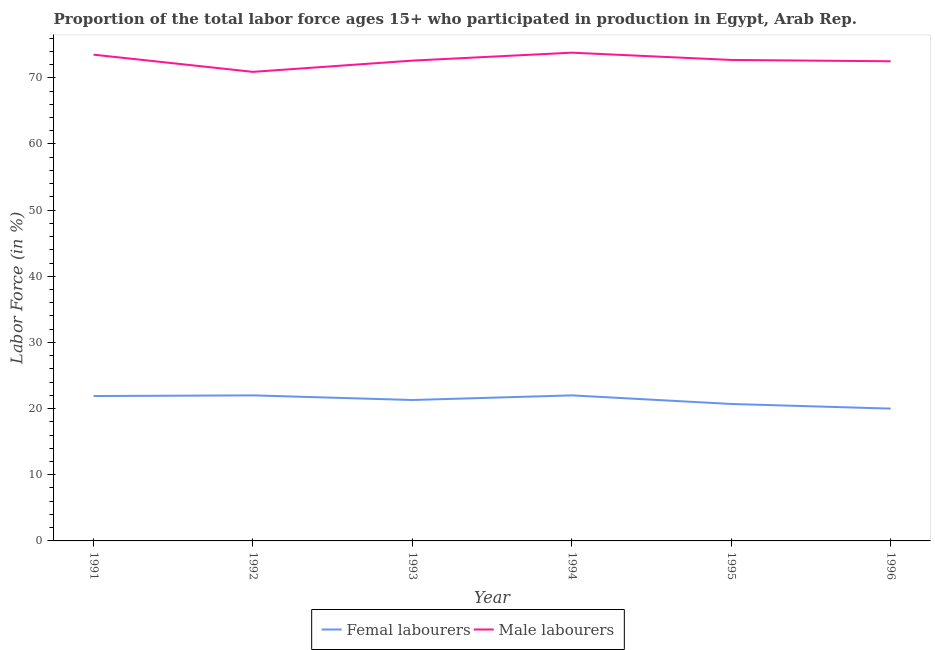How many different coloured lines are there?
Offer a very short reply. 2. What is the percentage of male labour force in 1994?
Keep it short and to the point. 73.8. Across all years, what is the minimum percentage of male labour force?
Give a very brief answer. 70.9. In which year was the percentage of male labour force minimum?
Provide a succinct answer. 1992. What is the total percentage of female labor force in the graph?
Your response must be concise. 127.9. What is the difference between the percentage of male labour force in 1994 and that in 1995?
Your answer should be compact. 1.1. What is the difference between the percentage of female labor force in 1992 and the percentage of male labour force in 1993?
Keep it short and to the point. -50.6. What is the average percentage of female labor force per year?
Your answer should be very brief. 21.32. In the year 1995, what is the difference between the percentage of male labour force and percentage of female labor force?
Offer a terse response. 52. What is the ratio of the percentage of female labor force in 1991 to that in 1992?
Your answer should be very brief. 1. Is the difference between the percentage of male labour force in 1991 and 1994 greater than the difference between the percentage of female labor force in 1991 and 1994?
Your response must be concise. No. In how many years, is the percentage of male labour force greater than the average percentage of male labour force taken over all years?
Your answer should be compact. 3. Is the percentage of female labor force strictly greater than the percentage of male labour force over the years?
Provide a succinct answer. No. How many years are there in the graph?
Provide a short and direct response. 6. What is the difference between two consecutive major ticks on the Y-axis?
Offer a terse response. 10. Are the values on the major ticks of Y-axis written in scientific E-notation?
Provide a short and direct response. No. Does the graph contain any zero values?
Provide a succinct answer. No. Does the graph contain grids?
Offer a very short reply. No. How many legend labels are there?
Provide a short and direct response. 2. What is the title of the graph?
Provide a short and direct response. Proportion of the total labor force ages 15+ who participated in production in Egypt, Arab Rep. Does "Goods" appear as one of the legend labels in the graph?
Your response must be concise. No. What is the label or title of the X-axis?
Offer a terse response. Year. What is the Labor Force (in %) of Femal labourers in 1991?
Your answer should be compact. 21.9. What is the Labor Force (in %) of Male labourers in 1991?
Your response must be concise. 73.5. What is the Labor Force (in %) of Male labourers in 1992?
Provide a short and direct response. 70.9. What is the Labor Force (in %) in Femal labourers in 1993?
Ensure brevity in your answer.  21.3. What is the Labor Force (in %) of Male labourers in 1993?
Offer a very short reply. 72.6. What is the Labor Force (in %) of Male labourers in 1994?
Provide a succinct answer. 73.8. What is the Labor Force (in %) of Femal labourers in 1995?
Provide a short and direct response. 20.7. What is the Labor Force (in %) of Male labourers in 1995?
Give a very brief answer. 72.7. What is the Labor Force (in %) of Male labourers in 1996?
Your answer should be very brief. 72.5. Across all years, what is the maximum Labor Force (in %) of Male labourers?
Your response must be concise. 73.8. Across all years, what is the minimum Labor Force (in %) in Femal labourers?
Provide a short and direct response. 20. Across all years, what is the minimum Labor Force (in %) in Male labourers?
Offer a very short reply. 70.9. What is the total Labor Force (in %) in Femal labourers in the graph?
Make the answer very short. 127.9. What is the total Labor Force (in %) in Male labourers in the graph?
Your response must be concise. 436. What is the difference between the Labor Force (in %) in Femal labourers in 1991 and that in 1992?
Provide a short and direct response. -0.1. What is the difference between the Labor Force (in %) of Male labourers in 1991 and that in 1993?
Offer a terse response. 0.9. What is the difference between the Labor Force (in %) of Male labourers in 1991 and that in 1994?
Make the answer very short. -0.3. What is the difference between the Labor Force (in %) of Femal labourers in 1991 and that in 1995?
Keep it short and to the point. 1.2. What is the difference between the Labor Force (in %) in Male labourers in 1991 and that in 1995?
Your answer should be compact. 0.8. What is the difference between the Labor Force (in %) of Femal labourers in 1991 and that in 1996?
Offer a terse response. 1.9. What is the difference between the Labor Force (in %) of Male labourers in 1991 and that in 1996?
Your response must be concise. 1. What is the difference between the Labor Force (in %) in Femal labourers in 1992 and that in 1995?
Give a very brief answer. 1.3. What is the difference between the Labor Force (in %) in Femal labourers in 1992 and that in 1996?
Your answer should be compact. 2. What is the difference between the Labor Force (in %) of Male labourers in 1993 and that in 1995?
Provide a short and direct response. -0.1. What is the difference between the Labor Force (in %) in Male labourers in 1993 and that in 1996?
Offer a very short reply. 0.1. What is the difference between the Labor Force (in %) of Femal labourers in 1994 and that in 1995?
Make the answer very short. 1.3. What is the difference between the Labor Force (in %) of Femal labourers in 1994 and that in 1996?
Your response must be concise. 2. What is the difference between the Labor Force (in %) in Male labourers in 1994 and that in 1996?
Provide a short and direct response. 1.3. What is the difference between the Labor Force (in %) of Femal labourers in 1995 and that in 1996?
Provide a succinct answer. 0.7. What is the difference between the Labor Force (in %) of Male labourers in 1995 and that in 1996?
Provide a short and direct response. 0.2. What is the difference between the Labor Force (in %) in Femal labourers in 1991 and the Labor Force (in %) in Male labourers in 1992?
Provide a succinct answer. -49. What is the difference between the Labor Force (in %) in Femal labourers in 1991 and the Labor Force (in %) in Male labourers in 1993?
Your answer should be very brief. -50.7. What is the difference between the Labor Force (in %) in Femal labourers in 1991 and the Labor Force (in %) in Male labourers in 1994?
Offer a very short reply. -51.9. What is the difference between the Labor Force (in %) in Femal labourers in 1991 and the Labor Force (in %) in Male labourers in 1995?
Offer a terse response. -50.8. What is the difference between the Labor Force (in %) in Femal labourers in 1991 and the Labor Force (in %) in Male labourers in 1996?
Offer a very short reply. -50.6. What is the difference between the Labor Force (in %) of Femal labourers in 1992 and the Labor Force (in %) of Male labourers in 1993?
Keep it short and to the point. -50.6. What is the difference between the Labor Force (in %) of Femal labourers in 1992 and the Labor Force (in %) of Male labourers in 1994?
Offer a very short reply. -51.8. What is the difference between the Labor Force (in %) of Femal labourers in 1992 and the Labor Force (in %) of Male labourers in 1995?
Keep it short and to the point. -50.7. What is the difference between the Labor Force (in %) in Femal labourers in 1992 and the Labor Force (in %) in Male labourers in 1996?
Make the answer very short. -50.5. What is the difference between the Labor Force (in %) in Femal labourers in 1993 and the Labor Force (in %) in Male labourers in 1994?
Your response must be concise. -52.5. What is the difference between the Labor Force (in %) in Femal labourers in 1993 and the Labor Force (in %) in Male labourers in 1995?
Offer a terse response. -51.4. What is the difference between the Labor Force (in %) in Femal labourers in 1993 and the Labor Force (in %) in Male labourers in 1996?
Offer a very short reply. -51.2. What is the difference between the Labor Force (in %) in Femal labourers in 1994 and the Labor Force (in %) in Male labourers in 1995?
Your answer should be very brief. -50.7. What is the difference between the Labor Force (in %) of Femal labourers in 1994 and the Labor Force (in %) of Male labourers in 1996?
Give a very brief answer. -50.5. What is the difference between the Labor Force (in %) in Femal labourers in 1995 and the Labor Force (in %) in Male labourers in 1996?
Keep it short and to the point. -51.8. What is the average Labor Force (in %) in Femal labourers per year?
Provide a short and direct response. 21.32. What is the average Labor Force (in %) in Male labourers per year?
Your answer should be very brief. 72.67. In the year 1991, what is the difference between the Labor Force (in %) in Femal labourers and Labor Force (in %) in Male labourers?
Make the answer very short. -51.6. In the year 1992, what is the difference between the Labor Force (in %) of Femal labourers and Labor Force (in %) of Male labourers?
Ensure brevity in your answer.  -48.9. In the year 1993, what is the difference between the Labor Force (in %) in Femal labourers and Labor Force (in %) in Male labourers?
Make the answer very short. -51.3. In the year 1994, what is the difference between the Labor Force (in %) in Femal labourers and Labor Force (in %) in Male labourers?
Give a very brief answer. -51.8. In the year 1995, what is the difference between the Labor Force (in %) in Femal labourers and Labor Force (in %) in Male labourers?
Give a very brief answer. -52. In the year 1996, what is the difference between the Labor Force (in %) in Femal labourers and Labor Force (in %) in Male labourers?
Your response must be concise. -52.5. What is the ratio of the Labor Force (in %) of Femal labourers in 1991 to that in 1992?
Your answer should be compact. 1. What is the ratio of the Labor Force (in %) in Male labourers in 1991 to that in 1992?
Keep it short and to the point. 1.04. What is the ratio of the Labor Force (in %) in Femal labourers in 1991 to that in 1993?
Provide a short and direct response. 1.03. What is the ratio of the Labor Force (in %) in Male labourers in 1991 to that in 1993?
Provide a succinct answer. 1.01. What is the ratio of the Labor Force (in %) in Femal labourers in 1991 to that in 1994?
Ensure brevity in your answer.  1. What is the ratio of the Labor Force (in %) of Male labourers in 1991 to that in 1994?
Make the answer very short. 1. What is the ratio of the Labor Force (in %) of Femal labourers in 1991 to that in 1995?
Provide a succinct answer. 1.06. What is the ratio of the Labor Force (in %) in Male labourers in 1991 to that in 1995?
Give a very brief answer. 1.01. What is the ratio of the Labor Force (in %) in Femal labourers in 1991 to that in 1996?
Offer a very short reply. 1.09. What is the ratio of the Labor Force (in %) of Male labourers in 1991 to that in 1996?
Make the answer very short. 1.01. What is the ratio of the Labor Force (in %) of Femal labourers in 1992 to that in 1993?
Give a very brief answer. 1.03. What is the ratio of the Labor Force (in %) in Male labourers in 1992 to that in 1993?
Your answer should be compact. 0.98. What is the ratio of the Labor Force (in %) in Male labourers in 1992 to that in 1994?
Make the answer very short. 0.96. What is the ratio of the Labor Force (in %) of Femal labourers in 1992 to that in 1995?
Give a very brief answer. 1.06. What is the ratio of the Labor Force (in %) of Male labourers in 1992 to that in 1995?
Make the answer very short. 0.98. What is the ratio of the Labor Force (in %) of Male labourers in 1992 to that in 1996?
Offer a terse response. 0.98. What is the ratio of the Labor Force (in %) of Femal labourers in 1993 to that in 1994?
Keep it short and to the point. 0.97. What is the ratio of the Labor Force (in %) of Male labourers in 1993 to that in 1994?
Make the answer very short. 0.98. What is the ratio of the Labor Force (in %) in Male labourers in 1993 to that in 1995?
Your response must be concise. 1. What is the ratio of the Labor Force (in %) in Femal labourers in 1993 to that in 1996?
Your answer should be compact. 1.06. What is the ratio of the Labor Force (in %) of Male labourers in 1993 to that in 1996?
Offer a very short reply. 1. What is the ratio of the Labor Force (in %) in Femal labourers in 1994 to that in 1995?
Give a very brief answer. 1.06. What is the ratio of the Labor Force (in %) of Male labourers in 1994 to that in 1995?
Provide a short and direct response. 1.02. What is the ratio of the Labor Force (in %) in Femal labourers in 1994 to that in 1996?
Ensure brevity in your answer.  1.1. What is the ratio of the Labor Force (in %) in Male labourers in 1994 to that in 1996?
Give a very brief answer. 1.02. What is the ratio of the Labor Force (in %) in Femal labourers in 1995 to that in 1996?
Give a very brief answer. 1.03. What is the ratio of the Labor Force (in %) of Male labourers in 1995 to that in 1996?
Your answer should be very brief. 1. What is the difference between the highest and the lowest Labor Force (in %) of Femal labourers?
Provide a short and direct response. 2. 